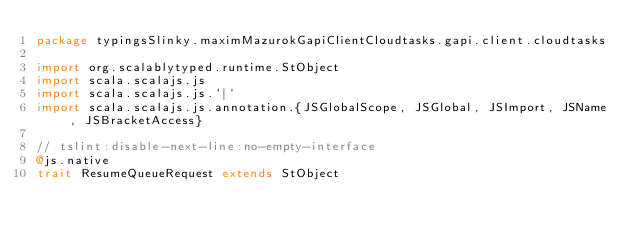<code> <loc_0><loc_0><loc_500><loc_500><_Scala_>package typingsSlinky.maximMazurokGapiClientCloudtasks.gapi.client.cloudtasks

import org.scalablytyped.runtime.StObject
import scala.scalajs.js
import scala.scalajs.js.`|`
import scala.scalajs.js.annotation.{JSGlobalScope, JSGlobal, JSImport, JSName, JSBracketAccess}

// tslint:disable-next-line:no-empty-interface
@js.native
trait ResumeQueueRequest extends StObject
</code> 